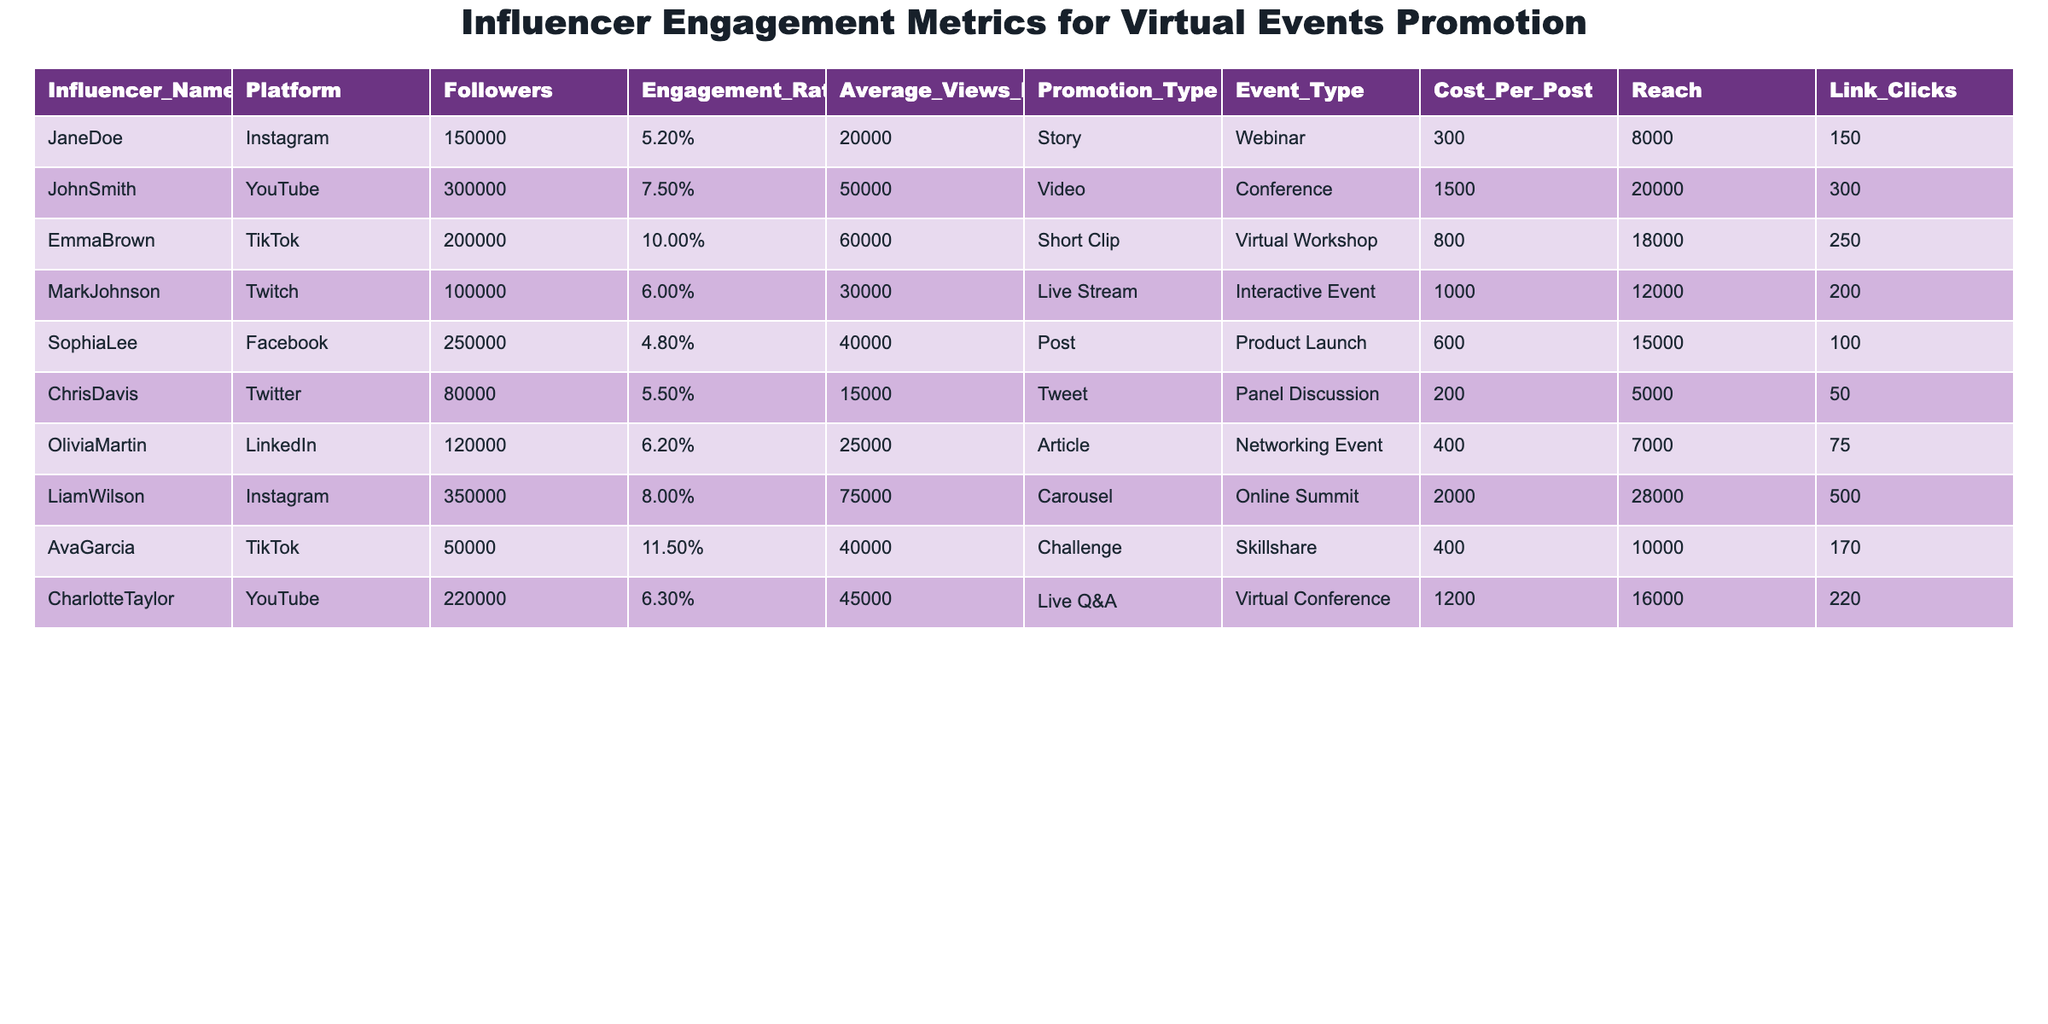What is the highest engagement rate among the influencers? By looking at the "Engagement_Rate" column, the highest value is listed for Ava Garcia at 11.5%.
Answer: 11.5% Which influencer has the most followers? According to the "Followers" column, Liam Wilson has the most followers with 350,000.
Answer: 350,000 How many clicks did Jane Doe's posts generate? Jane Doe's "Link_Clicks" value in the table shows she generated 150 clicks.
Answer: 150 What is the total cost for all influencers' posts? Adding the "Cost_Per_Post" amounts for each influencer gives: 300 + 1500 + 800 + 1000 + 600 + 200 + 400 + 2000 + 400 + 1200 = 8,100.
Answer: 8,100 Which platform has the highest average views per post? By comparing the "Average_Views_Per_Post" values, TikTok influencers have high averages, especially Emma Brown with 60,000 views.
Answer: TikTok Is there any influencer whose engagement rate is above 8%? Looking at the "Engagement_Rate" values, both Ava Garcia and Liam Wilson exceed 8%.
Answer: Yes What type of promotion does Mark Johnson use for his event? The "Promotion_Type" column shows that Mark Johnson uses "Live Stream" for his event.
Answer: Live Stream Calculate the average followers among Instagram influencers. The followers for Instagram influencers are 150,000 and 350,000. The average is (150,000 + 350,000) / 2 = 250,000.
Answer: 250,000 Which influencer has the highest cost per post? By checking the "Cost_Per_Post" column, Liam Wilson has the highest cost at 2,000.
Answer: 2,000 How many total link clicks were generated by influencers promoting virtual workshops? The influencers promoting a "Virtual Workshop" are Emma Brown and Ava Garcia, generating (250 + 170) = 420 total link clicks.
Answer: 420 What event type does the influencer with 250,000 followers promote? From the table, Sophia Lee promotes a "Product Launch" event type.
Answer: Product Launch Is the average views per post for YouTube influencers greater than 55,000? By looking at the "Average_Views_Per_Post" values for YouTube influencers (50,000 and 45,000), we find the average (50,000 + 45,000) / 2 = 47,500, which is less than 55,000.
Answer: No How many influencers have an engagement rate less than 6%? By checking the "Engagement_Rate" column, only Sophia Lee (4.8%) fits this criteria, so there is 1 influencer.
Answer: 1 Are there more influencers promoting webinars or conferences? The "Event_Type" column shows Jane Doe promoting a "Webinar" while John Smith promotes a "Conference", indicating there is 1 influencer for each.
Answer: Equal 